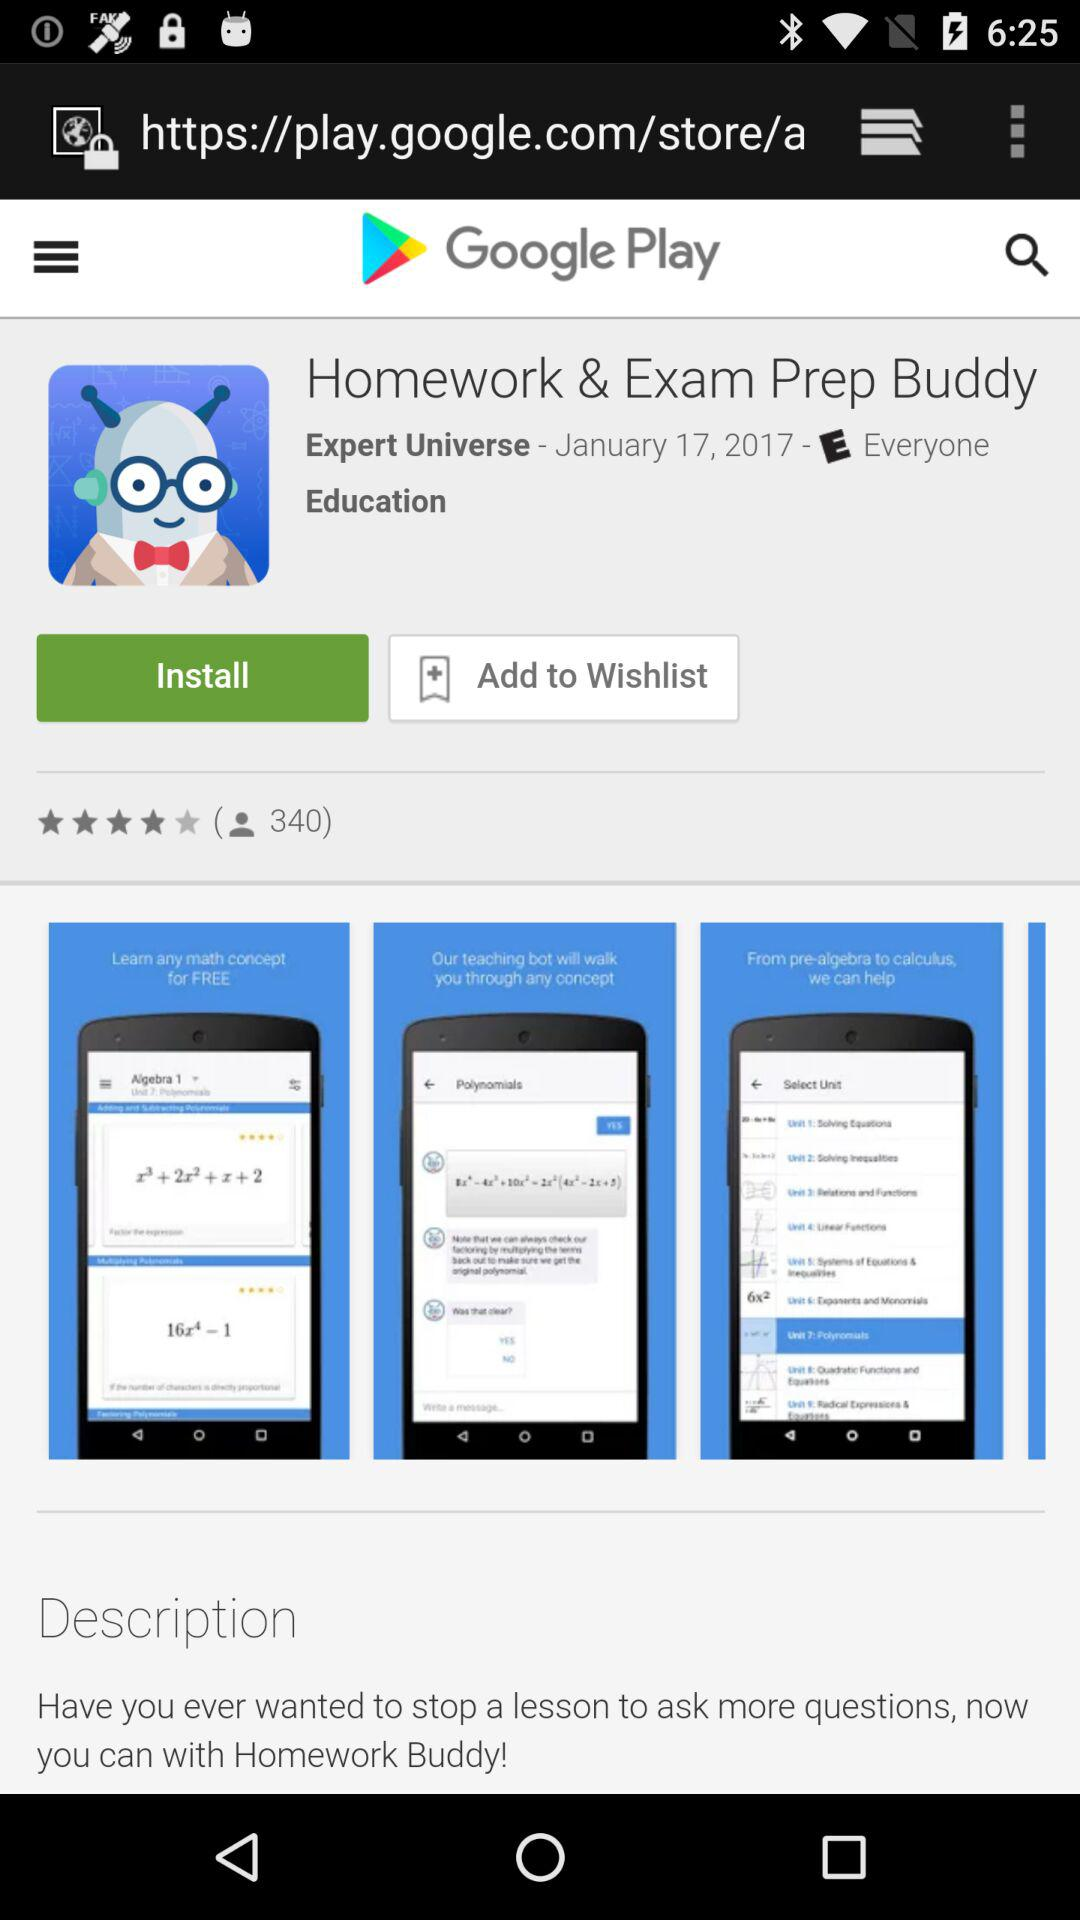On what date was the application Homework and Exam Prep Buddy released? The date is January 17, 2017. 